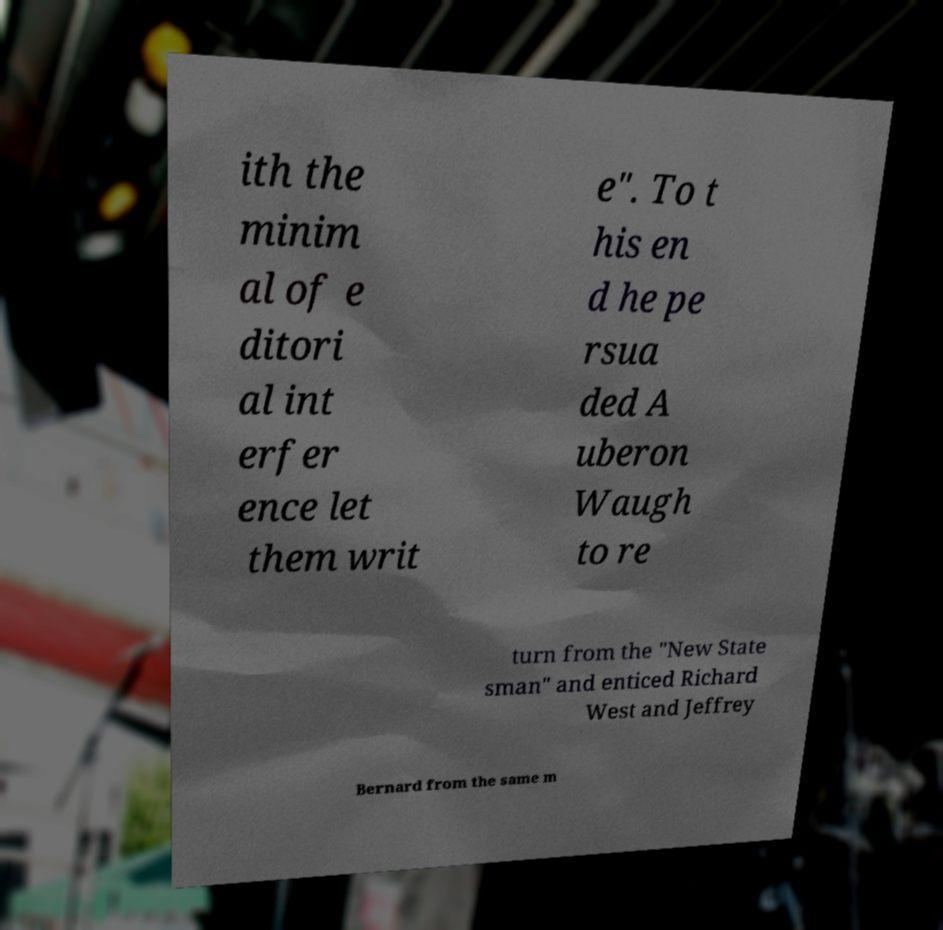Could you assist in decoding the text presented in this image and type it out clearly? ith the minim al of e ditori al int erfer ence let them writ e". To t his en d he pe rsua ded A uberon Waugh to re turn from the "New State sman" and enticed Richard West and Jeffrey Bernard from the same m 